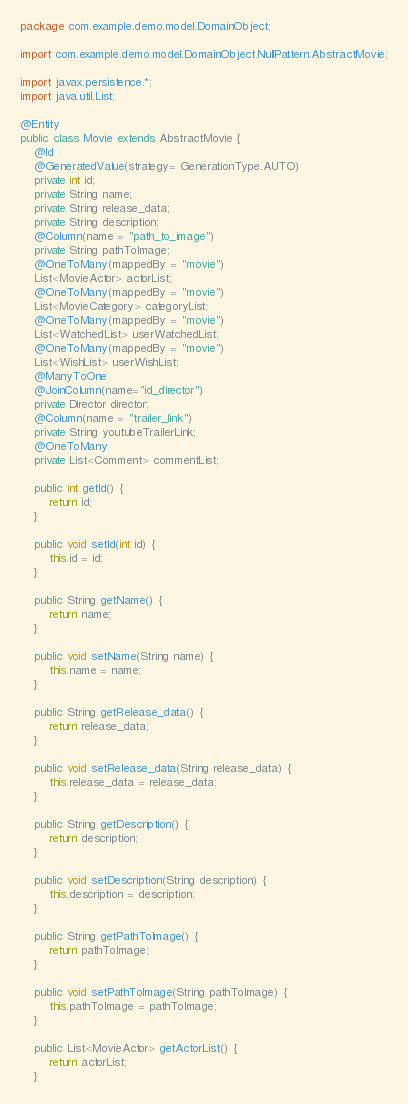Convert code to text. <code><loc_0><loc_0><loc_500><loc_500><_Java_>package com.example.demo.model.DomainObject;

import com.example.demo.model.DomainObject.NullPattern.AbstractMovie;

import javax.persistence.*;
import java.util.List;

@Entity
public class Movie extends AbstractMovie {
    @Id
    @GeneratedValue(strategy= GenerationType.AUTO)
    private int id;
    private String name;
    private String release_data;
    private String description;
    @Column(name = "path_to_image")
    private String pathToImage;
    @OneToMany(mappedBy = "movie")
    List<MovieActor> actorList;
    @OneToMany(mappedBy = "movie")
    List<MovieCategory> categoryList;
    @OneToMany(mappedBy = "movie")
    List<WatchedList> userWatchedList;
    @OneToMany(mappedBy = "movie")
    List<WishList> userWishList;
    @ManyToOne
    @JoinColumn(name="id_director")
    private Director director;
    @Column(name = "trailer_link")
    private String youtubeTrailerLink;
    @OneToMany
    private List<Comment> commentList;

    public int getId() {
        return id;
    }

    public void setId(int id) {
        this.id = id;
    }

    public String getName() {
        return name;
    }

    public void setName(String name) {
        this.name = name;
    }

    public String getRelease_data() {
        return release_data;
    }

    public void setRelease_data(String release_data) {
        this.release_data = release_data;
    }

    public String getDescription() {
        return description;
    }

    public void setDescription(String description) {
        this.description = description;
    }

    public String getPathToImage() {
        return pathToImage;
    }

    public void setPathToImage(String pathToImage) {
        this.pathToImage = pathToImage;
    }

    public List<MovieActor> getActorList() {
        return actorList;
    }
</code> 